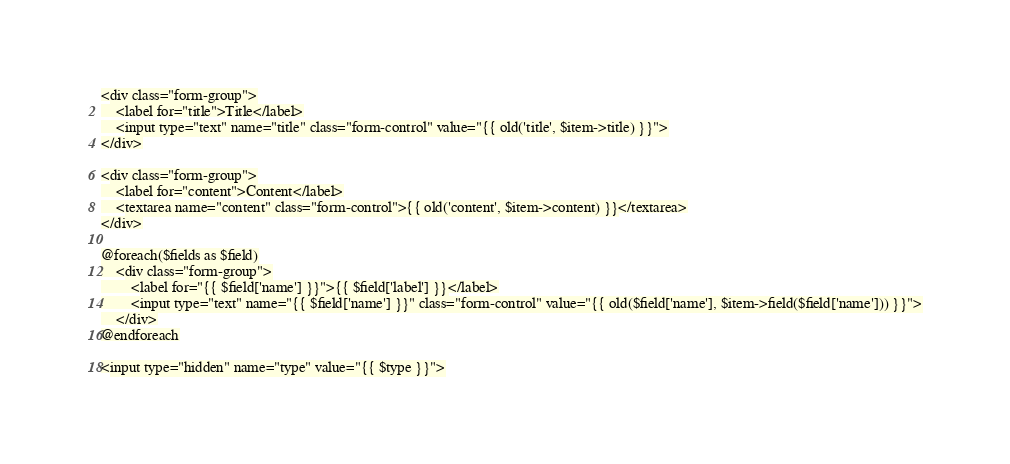Convert code to text. <code><loc_0><loc_0><loc_500><loc_500><_PHP_><div class="form-group">
	<label for="title">Title</label>
	<input type="text" name="title" class="form-control" value="{{ old('title', $item->title) }}">
</div>

<div class="form-group">
	<label for="content">Content</label>
	<textarea name="content" class="form-control">{{ old('content', $item->content) }}</textarea>
</div>

@foreach($fields as $field)
	<div class="form-group">
		<label for="{{ $field['name'] }}">{{ $field['label'] }}</label>
		<input type="text" name="{{ $field['name'] }}" class="form-control" value="{{ old($field['name'], $item->field($field['name'])) }}">
	</div>
@endforeach

<input type="hidden" name="type" value="{{ $type }}"></code> 